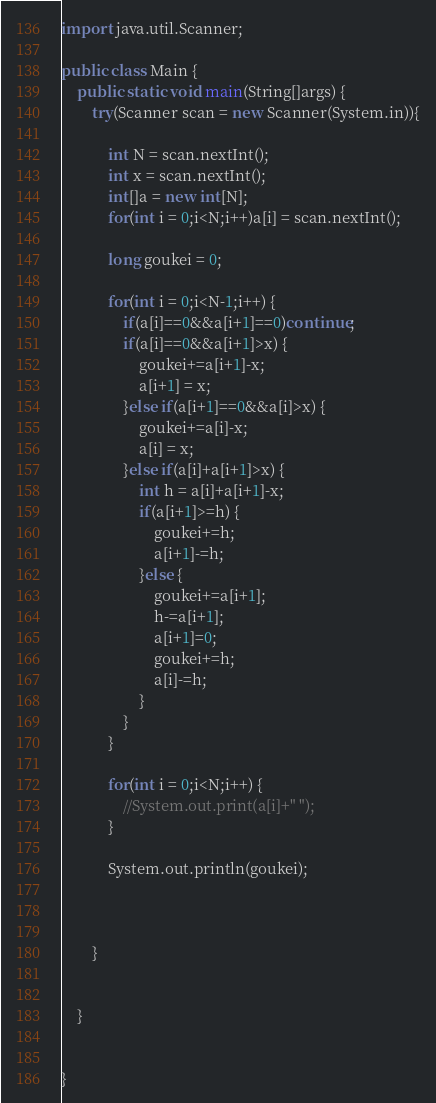Convert code to text. <code><loc_0><loc_0><loc_500><loc_500><_Java_>import java.util.Scanner;

public class Main {
	public static void main(String[]args) {
		try(Scanner scan = new Scanner(System.in)){
			
			int N = scan.nextInt();
			int x = scan.nextInt();
			int[]a = new int[N];
			for(int i = 0;i<N;i++)a[i] = scan.nextInt();
			
			long goukei = 0;
			
			for(int i = 0;i<N-1;i++) {
				if(a[i]==0&&a[i+1]==0)continue;
				if(a[i]==0&&a[i+1]>x) {
					goukei+=a[i+1]-x;
					a[i+1] = x;
				}else if(a[i+1]==0&&a[i]>x) {
					goukei+=a[i]-x;
					a[i] = x;
				}else if(a[i]+a[i+1]>x) {
					int h = a[i]+a[i+1]-x;
					if(a[i+1]>=h) {
						goukei+=h;
						a[i+1]-=h;
					}else {
						goukei+=a[i+1];
						h-=a[i+1];
						a[i+1]=0;
						goukei+=h;
						a[i]-=h;
					}
				}
			}
			
			for(int i = 0;i<N;i++) {
				//System.out.print(a[i]+" ");
			}
			
			System.out.println(goukei);
			
			
			
		}
		
		
	}
		

}
</code> 